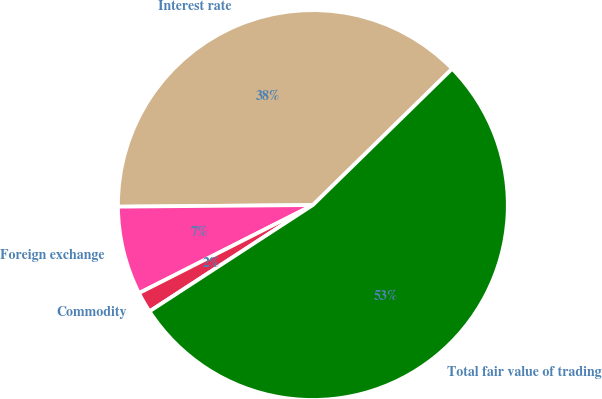Convert chart. <chart><loc_0><loc_0><loc_500><loc_500><pie_chart><fcel>Interest rate<fcel>Foreign exchange<fcel>Commodity<fcel>Total fair value of trading<nl><fcel>37.8%<fcel>7.33%<fcel>1.72%<fcel>53.14%<nl></chart> 